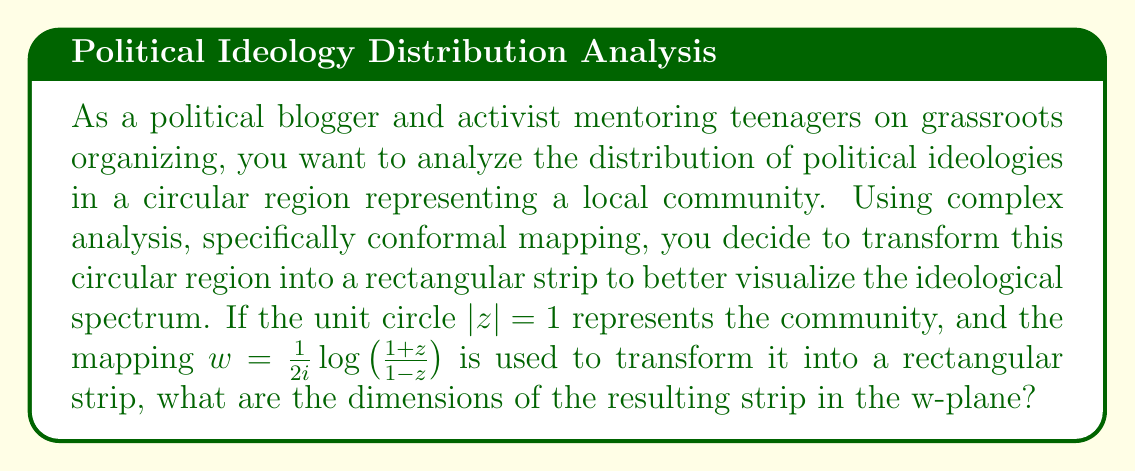Help me with this question. To solve this problem, we'll follow these steps:

1) The given conformal mapping is:

   $$w = \frac{1}{2i}\log\left(\frac{1+z}{1-z}\right)$$

2) This mapping is known as the Joukowski transformation, which maps the unit circle to a vertical strip in the w-plane.

3) To find the dimensions of the strip, we need to consider the behavior of this mapping on the unit circle $|z| = 1$.

4) On the unit circle, we can express z as $z = e^{i\theta}$, where $\theta \in [0, 2\pi]$.

5) Substituting this into our mapping:

   $$w = \frac{1}{2i}\log\left(\frac{1+e^{i\theta}}{1-e^{i\theta}}\right)$$

6) Simplifying the fraction inside the logarithm:

   $$w = \frac{1}{2i}\log\left(\frac{e^{-i\theta/2}+e^{i\theta/2}}{e^{-i\theta/2}-e^{i\theta/2}}\right) = \frac{1}{2i}\log\left(i\cot\frac{\theta}{2}\right)$$

7) Using the properties of logarithms:

   $$w = \frac{1}{2i}\left[\log(i) + \log\left(\cot\frac{\theta}{2}\right)\right] = \frac{1}{2i}\left[\frac{\pi i}{2} + \log\left(\cot\frac{\theta}{2}\right)\right]$$

8) Simplifying:

   $$w = \frac{\pi}{4} - \frac{1}{2i}\log\left(\cot\frac{\theta}{2}\right) = \frac{\pi}{4} + \frac{i}{2}\log\left(\tan\frac{\theta}{2}\right)$$

9) As $\theta$ varies from 0 to $2\pi$, $\tan\frac{\theta}{2}$ varies from 0 to $\infty$, then from $-\infty$ to 0.

10) This means the imaginary part of w varies from $-\infty$ to $+\infty$.

11) The real part of w is constant at $\frac{\pi}{4}$.

Therefore, the resulting strip in the w-plane has a width of $\frac{\pi}{2}$ (from $-\frac{\pi}{4}$ to $\frac{\pi}{4}$) and infinite height.
Answer: The dimensions of the resulting strip in the w-plane are: width = $\frac{\pi}{2}$, height = infinite. 